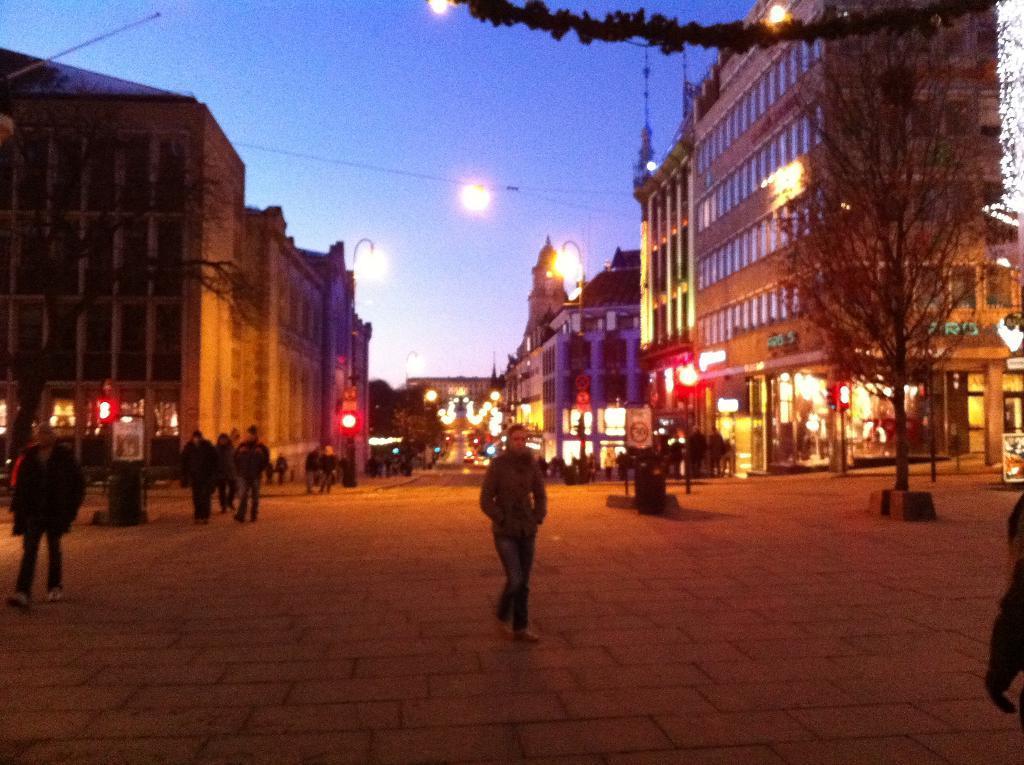Describe this image in one or two sentences. In this picture we can see a few people on the path. There are some boards, lights, buildings, other objects and the sky. 